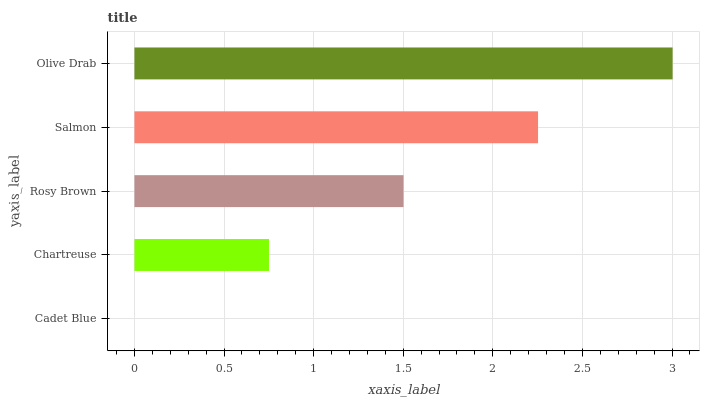Is Cadet Blue the minimum?
Answer yes or no. Yes. Is Olive Drab the maximum?
Answer yes or no. Yes. Is Chartreuse the minimum?
Answer yes or no. No. Is Chartreuse the maximum?
Answer yes or no. No. Is Chartreuse greater than Cadet Blue?
Answer yes or no. Yes. Is Cadet Blue less than Chartreuse?
Answer yes or no. Yes. Is Cadet Blue greater than Chartreuse?
Answer yes or no. No. Is Chartreuse less than Cadet Blue?
Answer yes or no. No. Is Rosy Brown the high median?
Answer yes or no. Yes. Is Rosy Brown the low median?
Answer yes or no. Yes. Is Chartreuse the high median?
Answer yes or no. No. Is Olive Drab the low median?
Answer yes or no. No. 